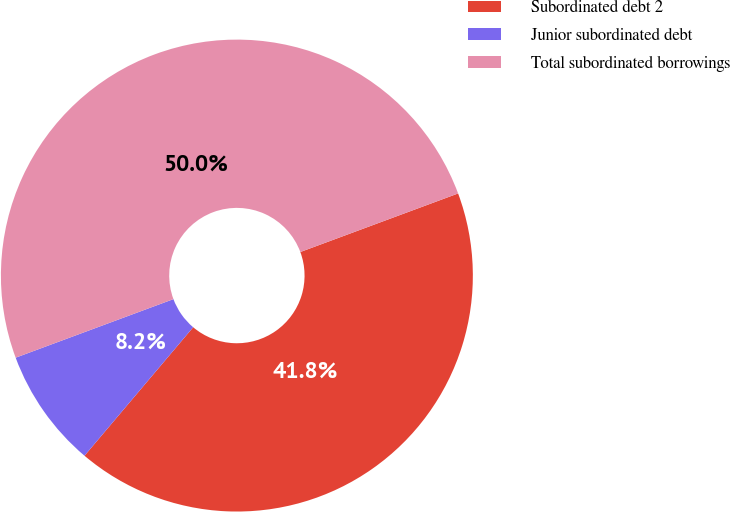<chart> <loc_0><loc_0><loc_500><loc_500><pie_chart><fcel>Subordinated debt 2<fcel>Junior subordinated debt<fcel>Total subordinated borrowings<nl><fcel>41.83%<fcel>8.17%<fcel>50.0%<nl></chart> 